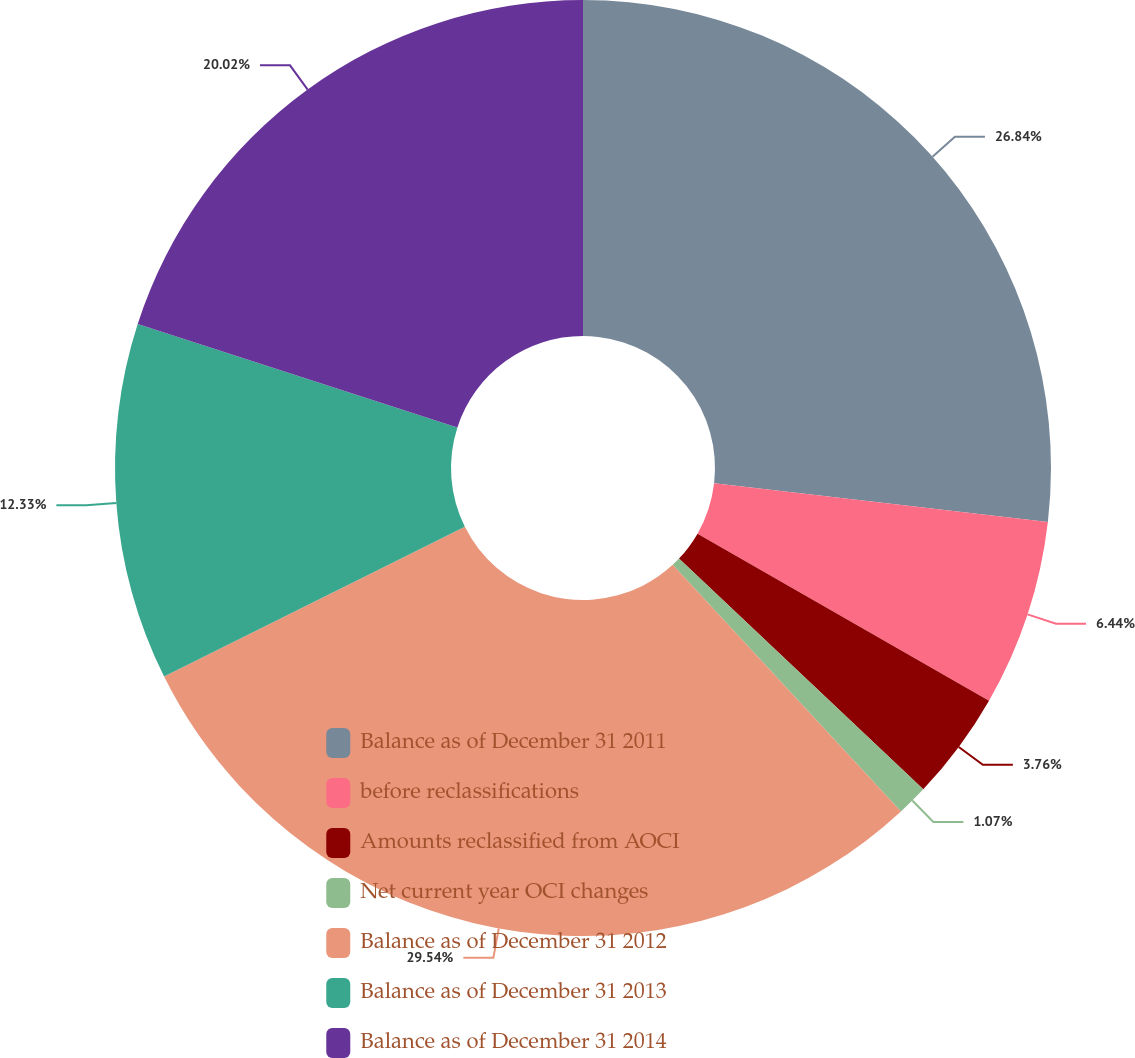Convert chart. <chart><loc_0><loc_0><loc_500><loc_500><pie_chart><fcel>Balance as of December 31 2011<fcel>before reclassifications<fcel>Amounts reclassified from AOCI<fcel>Net current year OCI changes<fcel>Balance as of December 31 2012<fcel>Balance as of December 31 2013<fcel>Balance as of December 31 2014<nl><fcel>26.84%<fcel>6.44%<fcel>3.76%<fcel>1.07%<fcel>29.53%<fcel>12.33%<fcel>20.02%<nl></chart> 